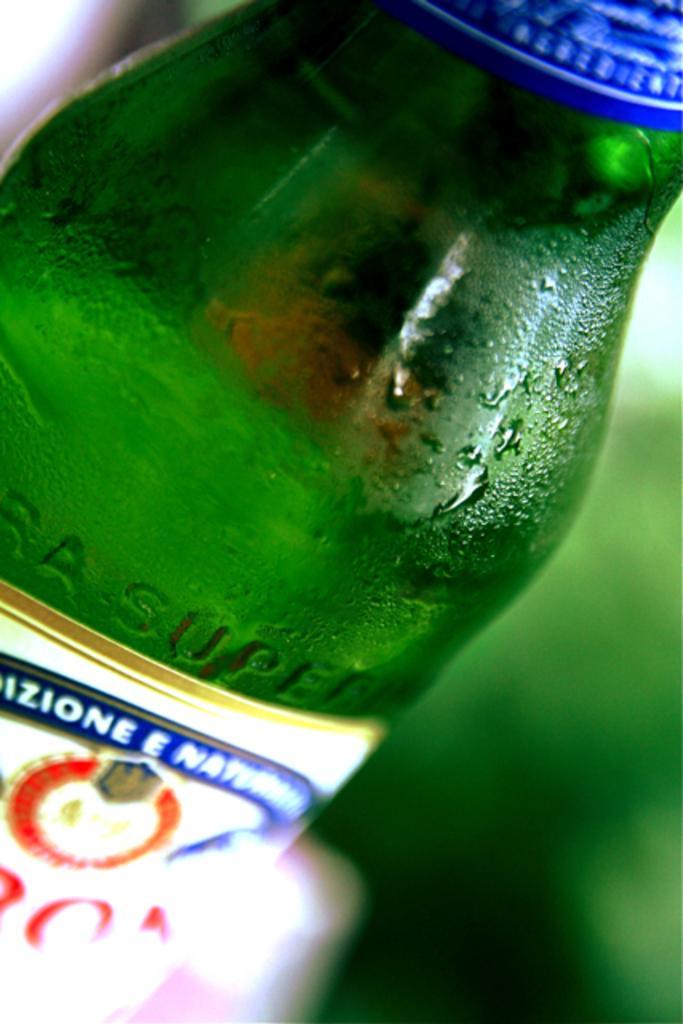Can you describe this image briefly? In this image I can see a bottle. 